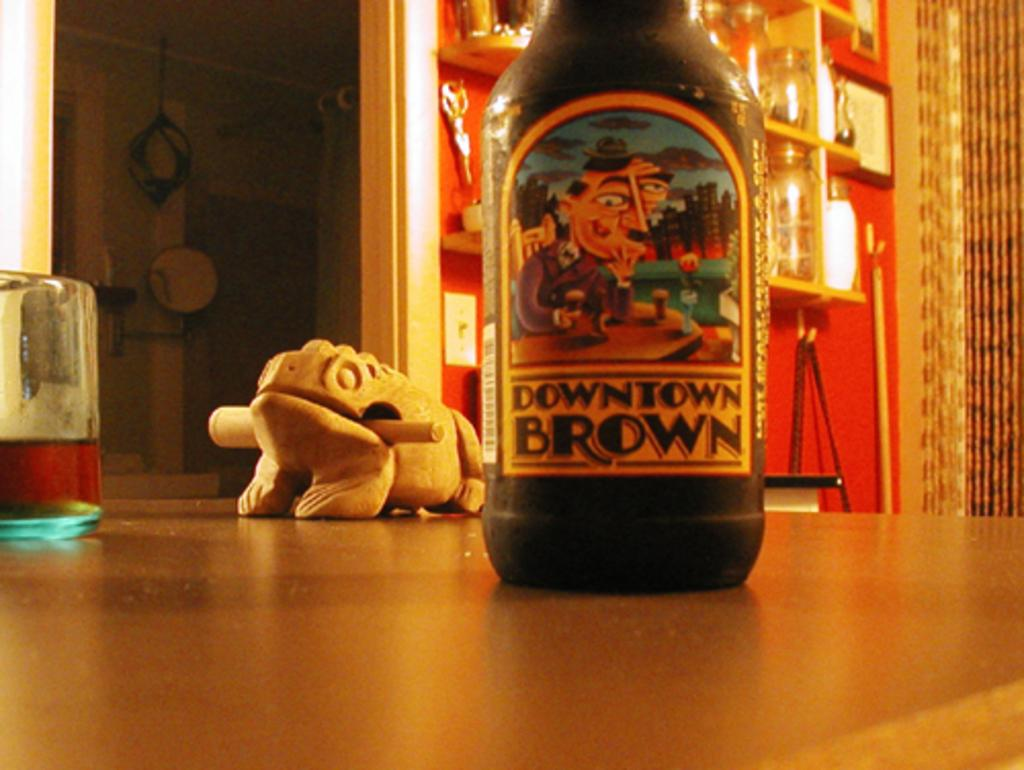<image>
Relay a brief, clear account of the picture shown. The large bottle of Downtown Brown beer sits on the table next to a large wooden frog figurine. 